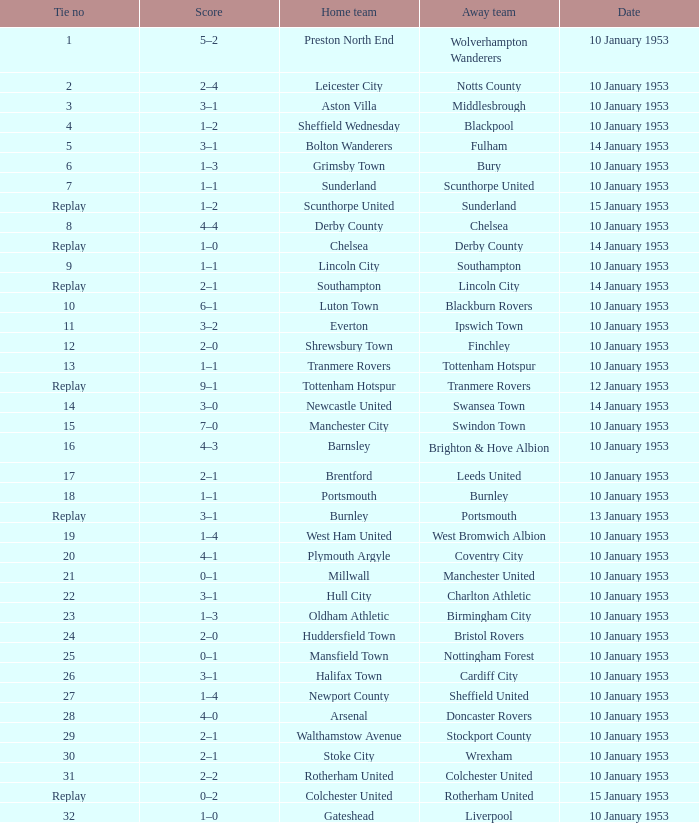What score has charlton athletic as the away team? 3–1. 